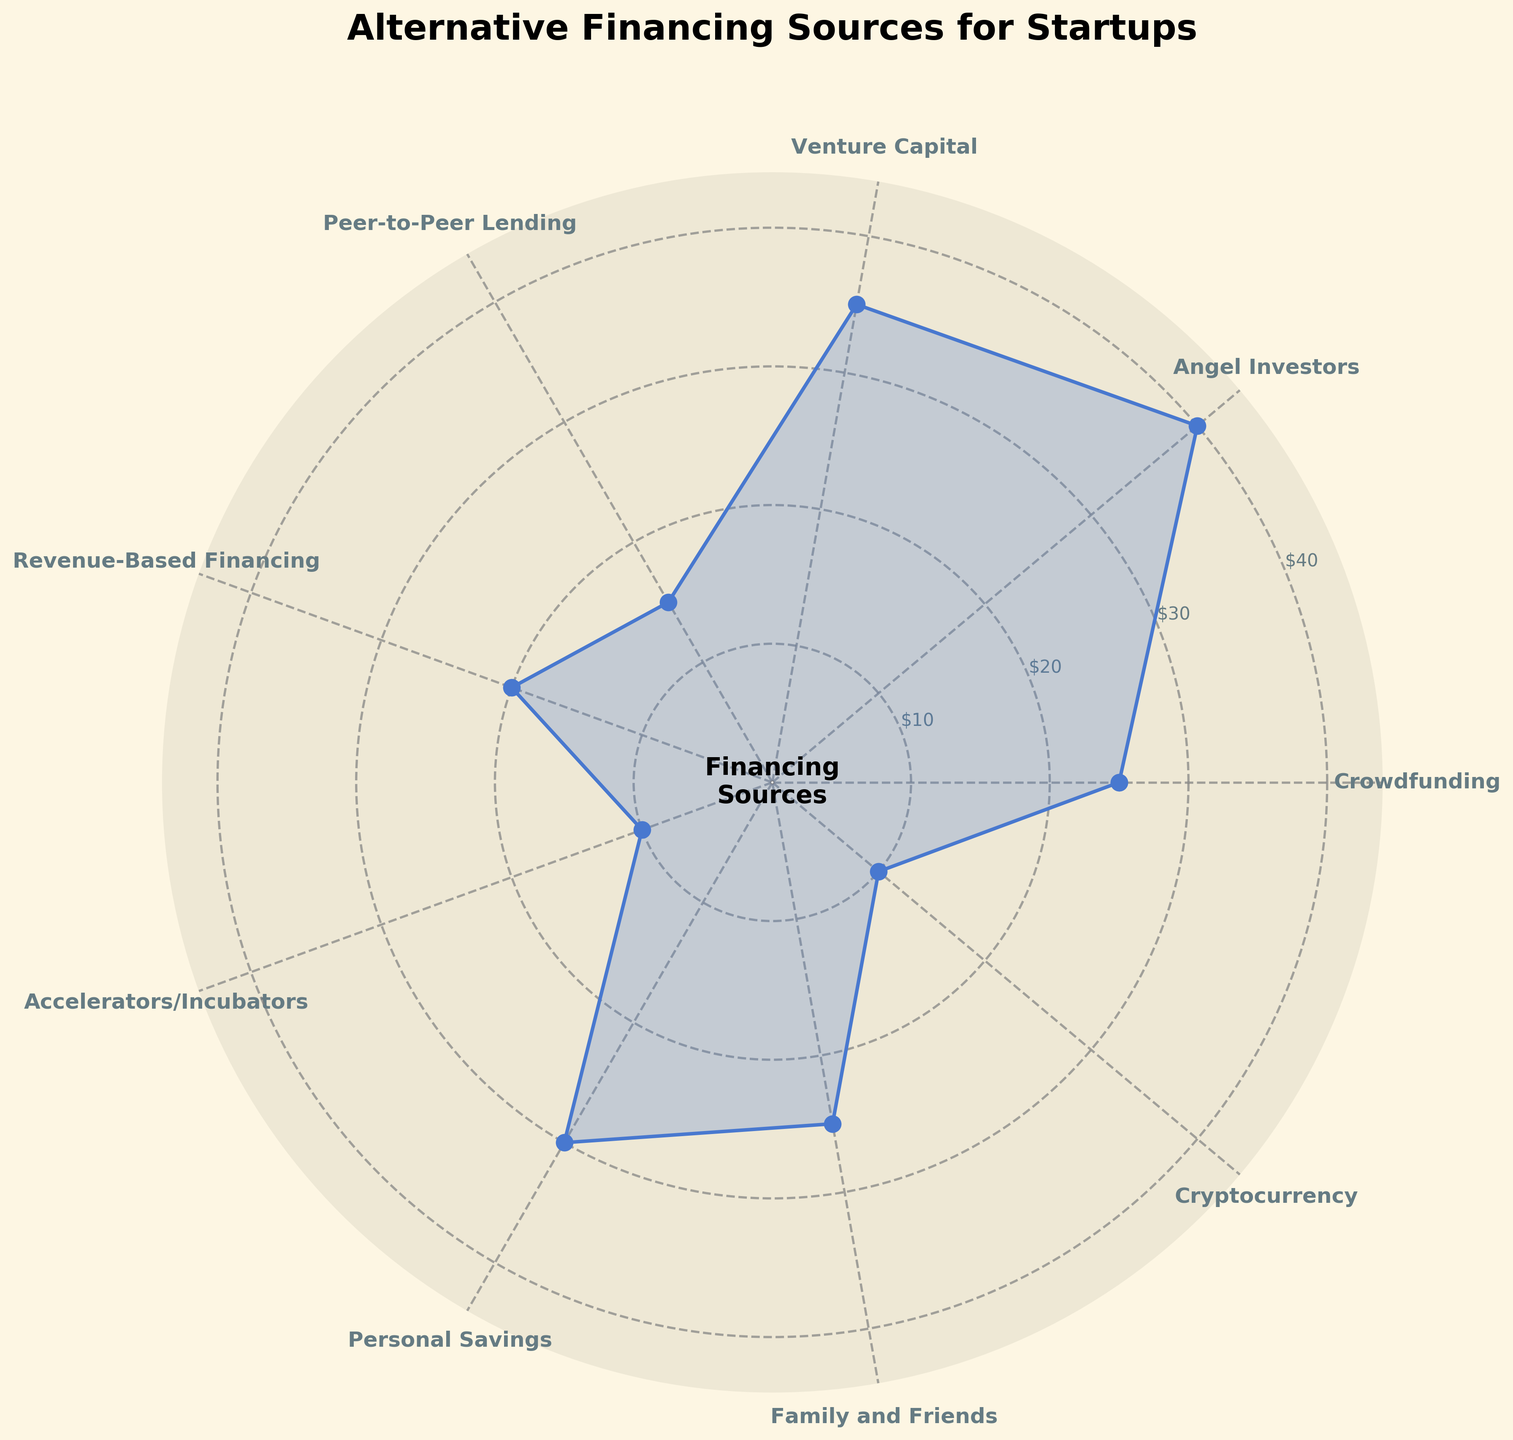What is the title of the chart? The title is written at the top of the chart, and it helps in understanding the subject matter of the visualized data.
Answer: Alternative Financing Sources for Startups Which category has the highest amount of financing? By looking at the height of the areas extending from the center to the perimeter, the category with the maximum coverage represents the highest amount of financing.
Answer: Angel Investors How many categories are listed in this chart? Counting the labels around the perimeter of the chart gives the total number of different categories presented.
Answer: 9 What are the categories that have an amount of 10? By examining the radial ticks and the corresponding labels at the outermost edge of the chart, the categories with radial lengths matching 10 can be identified.
Answer: Accelerators/Incubators, Cryptocurrency What is the combined amount of financing for Crowdfunding and Family and Friends? Adding the amounts given for the two categories Crowdfunding (25) and Family and Friends (25) results in the total combined amount. 25 + 25 = 50
Answer: 50 Which has a greater amount of financing: Revenue-Based Financing or Personal Savings? Comparing the radial lengths corresponding to Revenue-Based Financing and Personal Savings by looking at their respective areas and values.
Answer: Personal Savings By how much does the Angel Investors category exceed Peer-to-Peer Lending? Subtract the amount for Peer-to-Peer Lending (15) from the amount for Angel Investors (40) to find the difference. 40 - 15 = 25
Answer: 25 Which two categories have a total financing amount equal to Venture Capital? Identifying categories whose sum of values equals Venture Capital's amount (35), Crowdfunding (25) and Accelerators/Incubators (10) make up the total. 25 + 10 = 35
Answer: Crowdfunding and Accelerators/Incubators Is there a category listed that represents alternative financing using digital currency? By reading the names of the categories, looking for any that suggest digital currency, such as Cryptocurrency.
Answer: Yes What is the average amount of financing across all categories? Summing all category amounts and dividing by the number of categories: (25 + 40 + 35 + 15 + 20 + 10 + 30 + 25 + 10) / 9 = 23.33
Answer: 23.33 